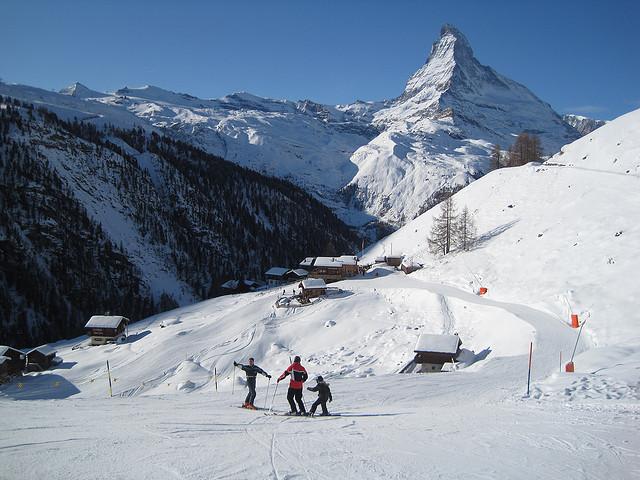Is there snow?
Be succinct. Yes. What species of tree is visible?
Write a very short answer. Pine. Is it cold outside?
Write a very short answer. Yes. Do you know which mountain this is?
Answer briefly. No. 